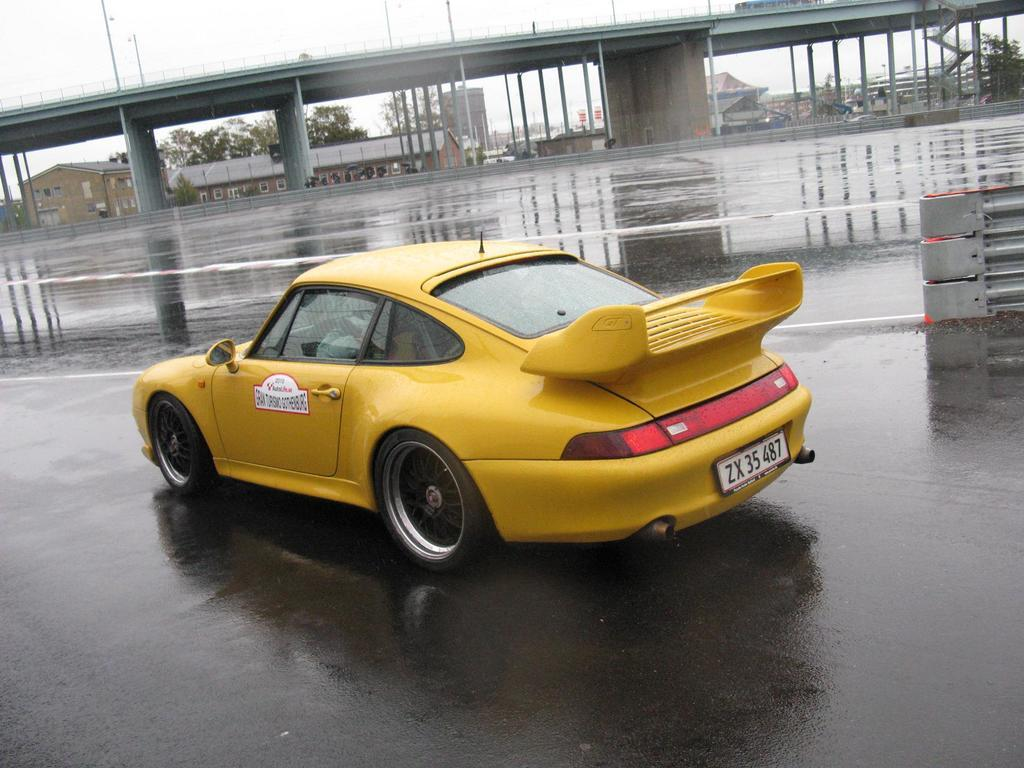What type of setting is depicted in the image? The image is an outside view. What can be seen on the road in the image? There is a yellow color car on the road. What is visible in the background of the image? There is a bridge, buildings, and trees in the background of the image. What is visible at the top of the image? The sky is visible at the top of the image. What type of cord is being used to connect the representative to the church in the image? There is no representative or church present in the image, and therefore no such cord or connection can be observed. 